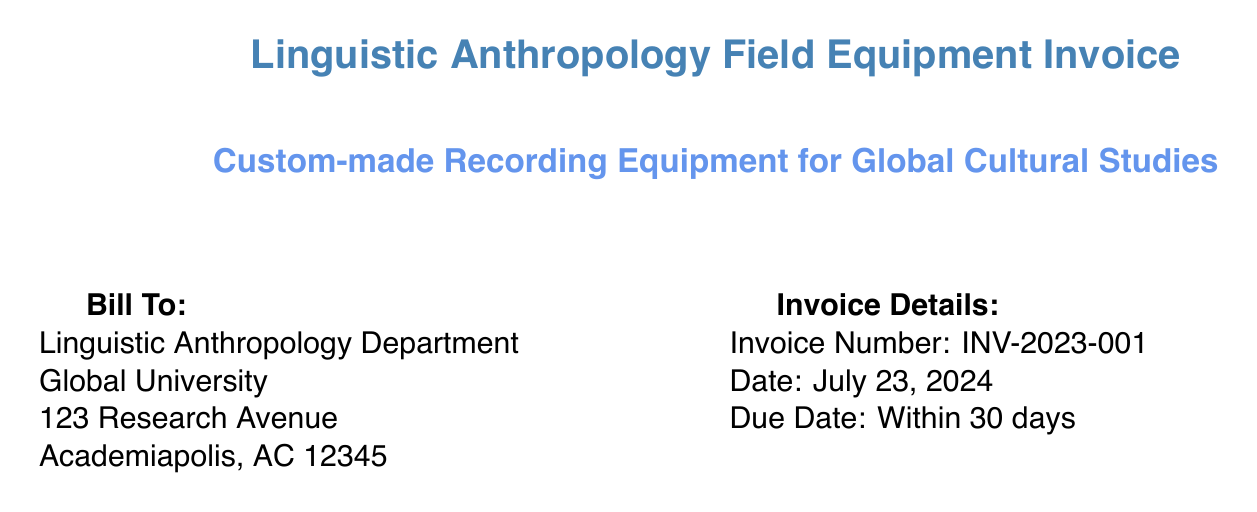what is the total cost of the equipment? The total cost is provided at the bottom of the invoice, which includes the subtotal, tax, and shipping.
Answer: $13,377.97 how many Sennheiser MKH 8040 microphones were purchased? The invoice lists the quantity of Sennheiser MKH 8040 microphones purchased.
Answer: 2 what is the unit price of the Aquarian Audio H2a-XLR Hydrophone? The invoice specifies the unit price for the Aquarian Audio H2a-XLR Hydrophone.
Answer: $299.00 what service is provided for non-waterproof equipment? The invoice mentions a specific service for non-waterproof equipment.
Answer: Custom waterproofing service what is the quantity of Sony MDR-7506 Professional Headphones? The invoice indicates how many Sony MDR-7506 Professional Headphones were included in the order.
Answer: 2 how much is the tax charged on the invoice? The tax amount is listed explicitly in the invoice totals.
Answer: $1,193.45 what consultation service is included in the invoice? The invoice describes a specific service related to equipment setup and consultation.
Answer: Field technician consultation and equipment setup what is the due date for the payment? The invoice explicitly states the payment due date for clarity.
Answer: Within 30 days what is the description of the Goal Zero Yeti 400 Portable Power Station? The invoice provides a brief description of the Goal Zero Yeti 400 Portable Power Station.
Answer: Rechargeable battery pack for powering equipment in remote locations 